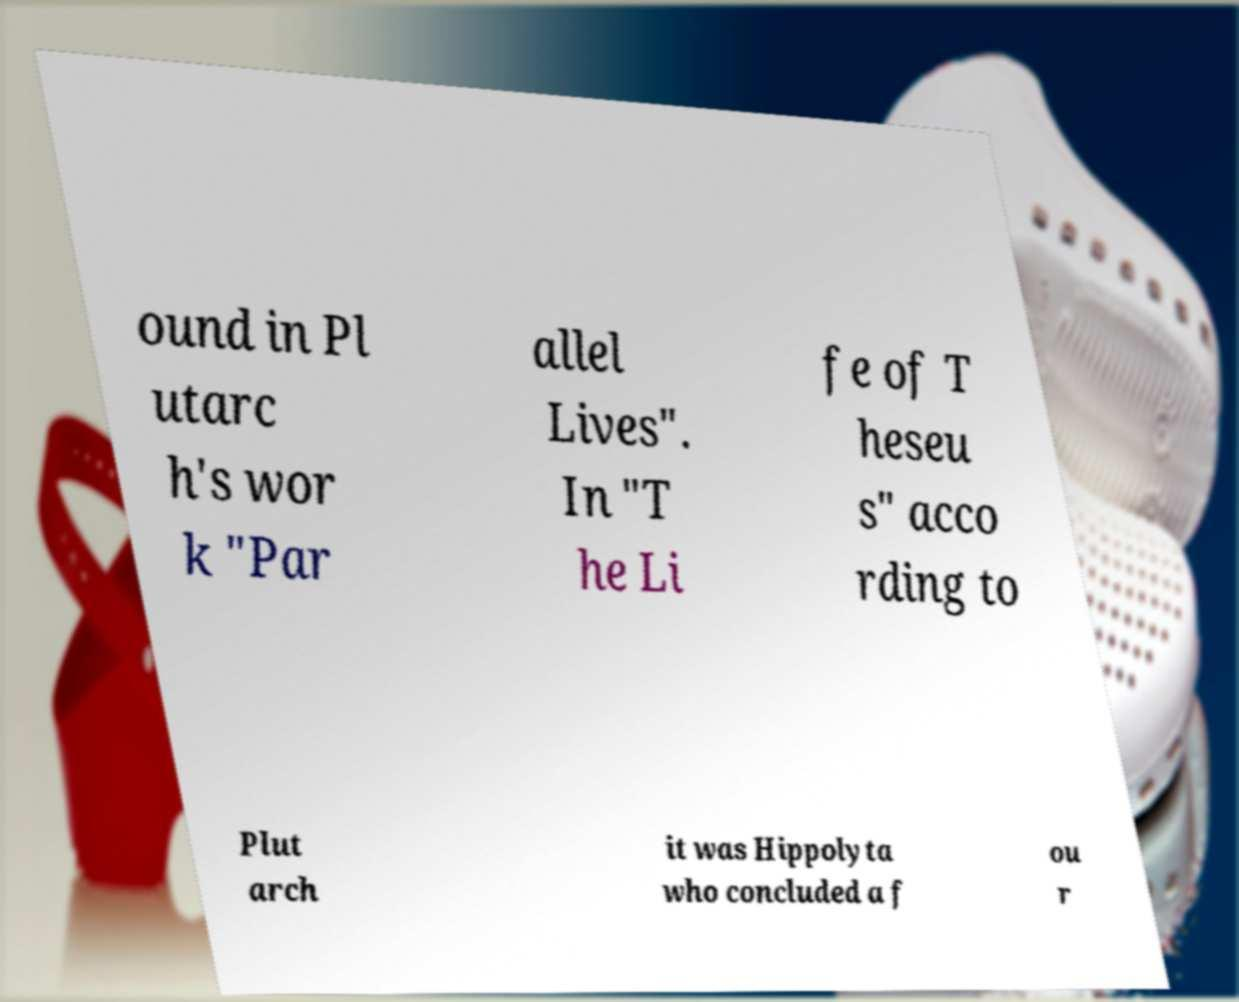There's text embedded in this image that I need extracted. Can you transcribe it verbatim? ound in Pl utarc h's wor k "Par allel Lives". In "T he Li fe of T heseu s" acco rding to Plut arch it was Hippolyta who concluded a f ou r 